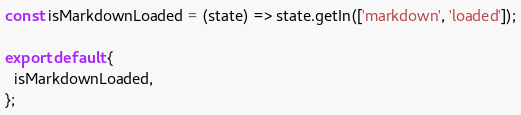<code> <loc_0><loc_0><loc_500><loc_500><_JavaScript_>const isMarkdownLoaded = (state) => state.getIn(['markdown', 'loaded']);

export default {
  isMarkdownLoaded,
};
</code> 